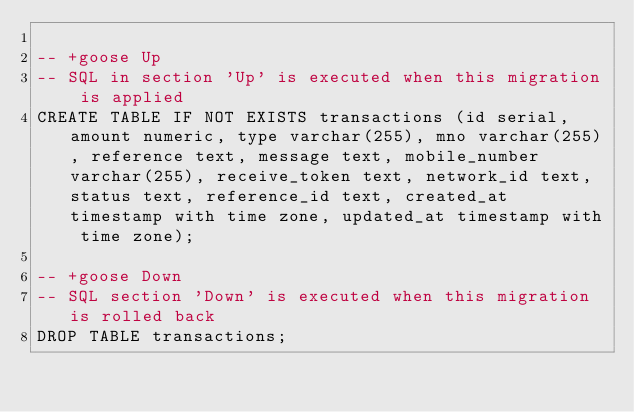Convert code to text. <code><loc_0><loc_0><loc_500><loc_500><_SQL_>
-- +goose Up
-- SQL in section 'Up' is executed when this migration is applied
CREATE TABLE IF NOT EXISTS transactions (id serial, amount numeric, type varchar(255), mno varchar(255), reference text, message text, mobile_number varchar(255), receive_token text, network_id text, status text, reference_id text, created_at timestamp with time zone, updated_at timestamp with time zone);

-- +goose Down
-- SQL section 'Down' is executed when this migration is rolled back
DROP TABLE transactions;
</code> 